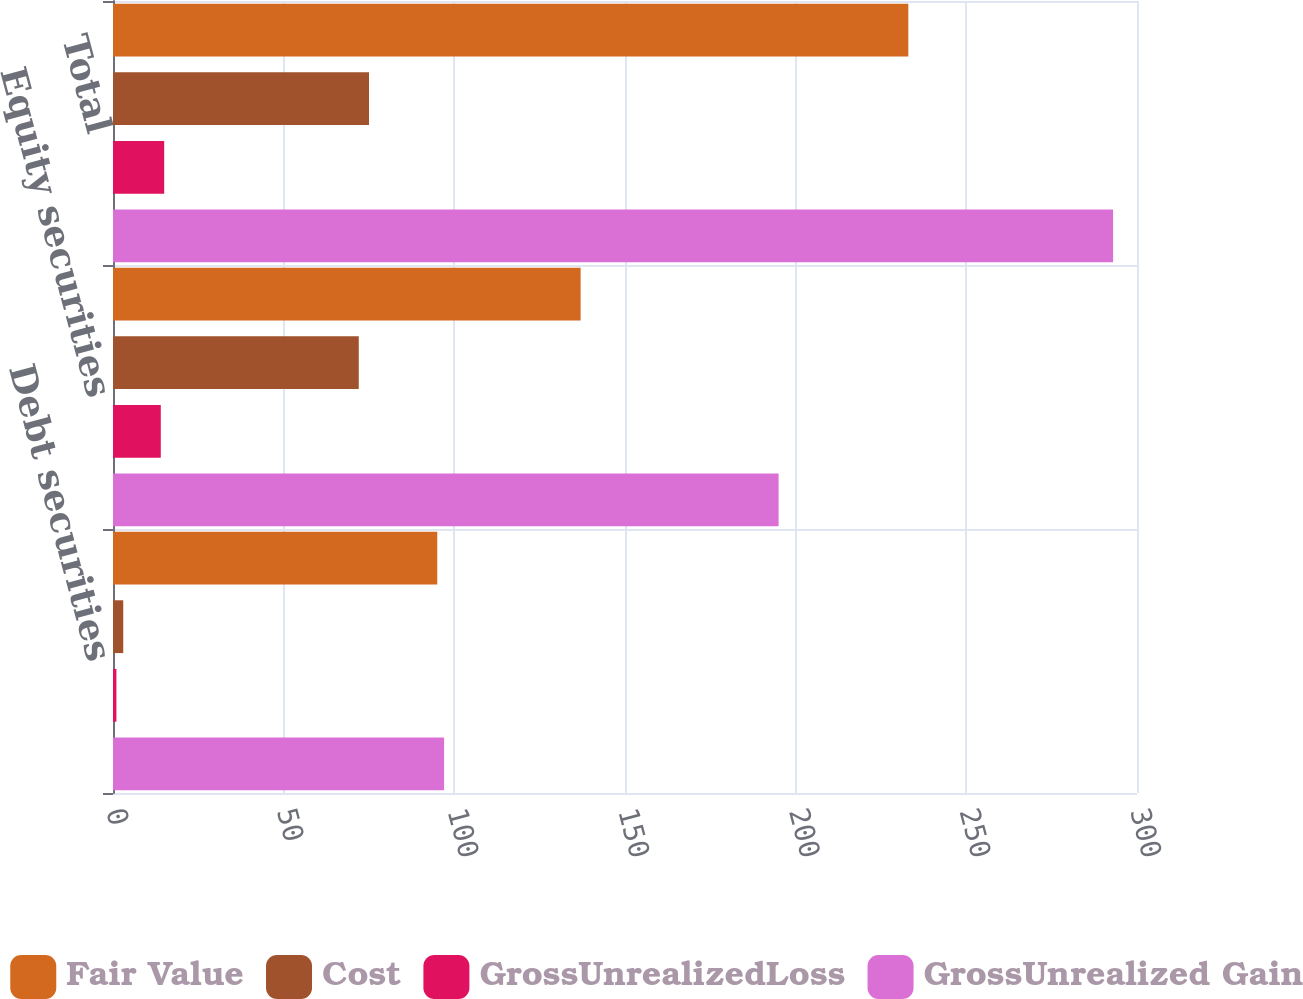Convert chart. <chart><loc_0><loc_0><loc_500><loc_500><stacked_bar_chart><ecel><fcel>Debt securities<fcel>Equity securities<fcel>Total<nl><fcel>Fair Value<fcel>95<fcel>137<fcel>233<nl><fcel>Cost<fcel>3<fcel>72<fcel>75<nl><fcel>GrossUnrealizedLoss<fcel>1<fcel>14<fcel>15<nl><fcel>GrossUnrealized Gain<fcel>97<fcel>195<fcel>293<nl></chart> 